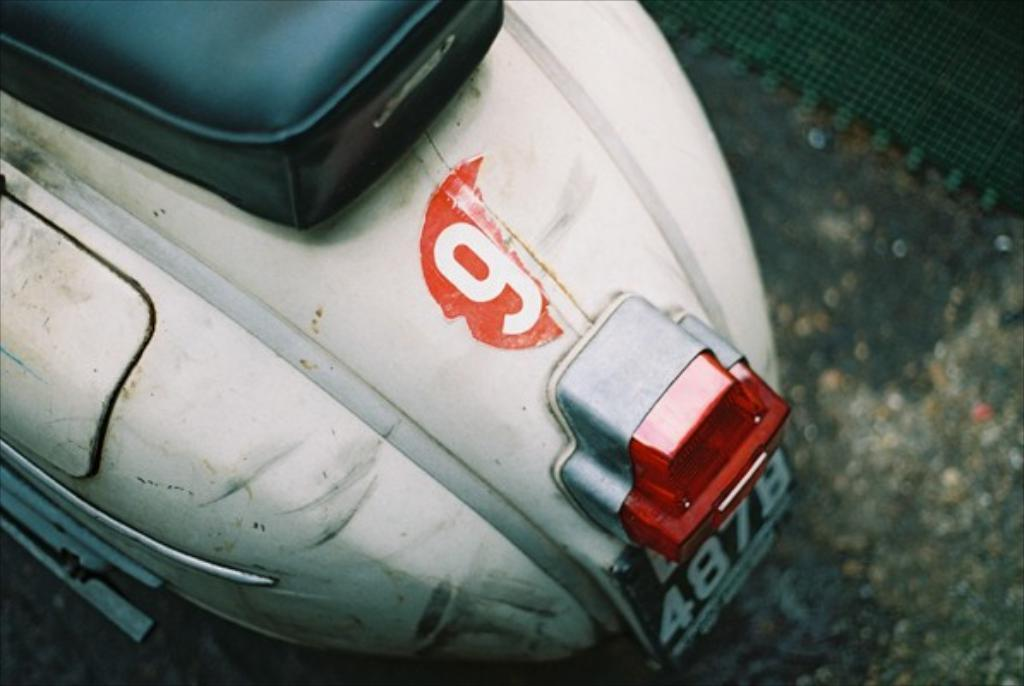What type of vehicle is in the image? There is a scooter in the image. Where is the scooter located? The scooter is on the road. How far can the lake be seen from the scooter in the image? There is no lake present in the image, so it cannot be seen from the scooter. 